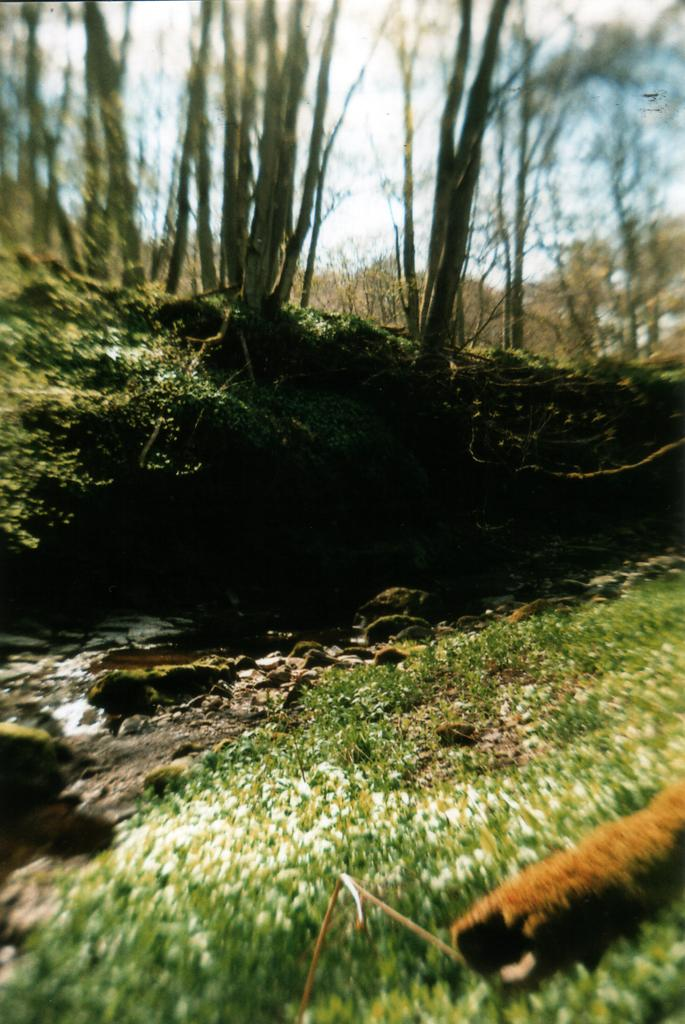What type of vegetation is present in the image? There is grass in the image. What other objects can be seen in the image? There are stones and trees visible in the image. What is the water feature in the image? The water is visible in the image. What part of the natural environment is visible in the image? The sky is visible in the image. Where is the maid standing in the image? There is no maid present in the image. What type of crook can be seen in the image? There is no crook present in the image. 